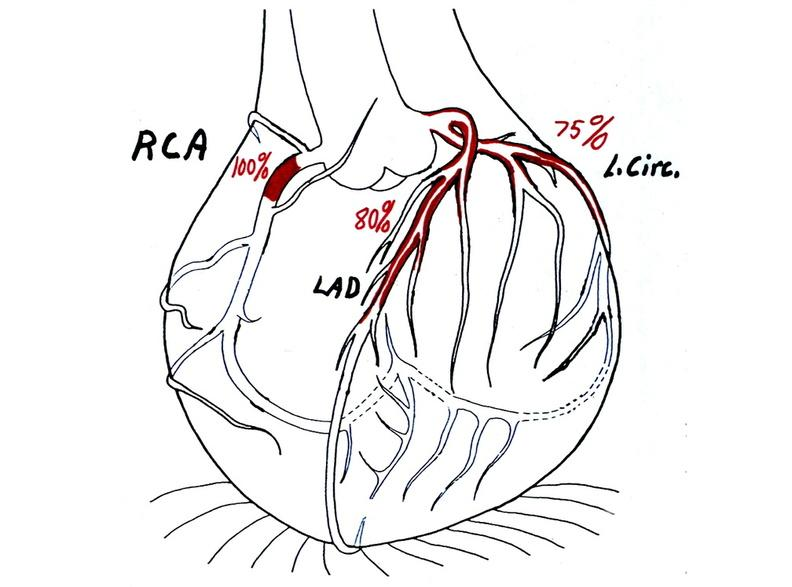s slide present?
Answer the question using a single word or phrase. No 